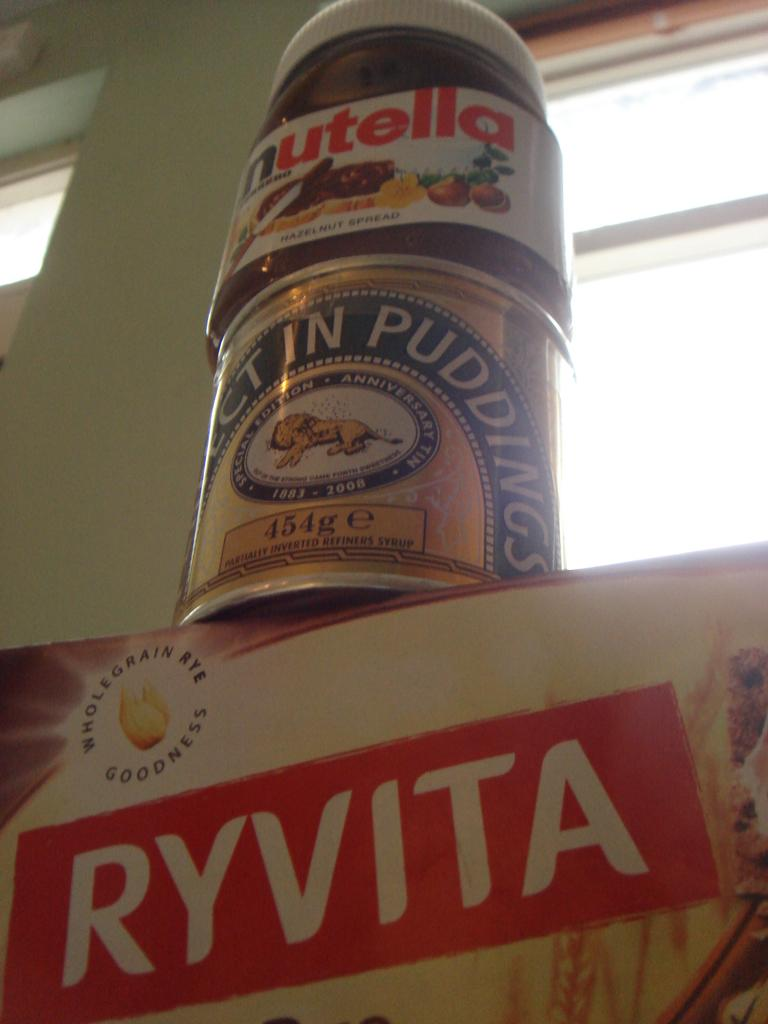<image>
Summarize the visual content of the image. A container of Nutella stacked on top of Pudding and Ryvita. 